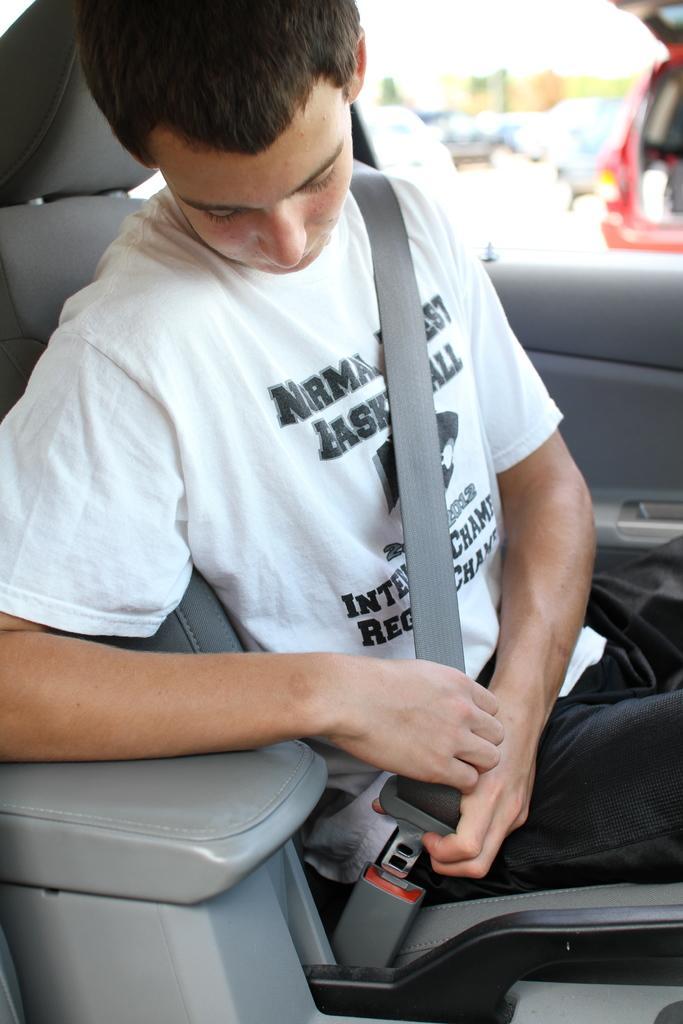In one or two sentences, can you explain what this image depicts? There is a man sitting in the car with white shirt. He is keeping seat belt. And there is a door and a seat. And outside that right corner we can see a red car. 